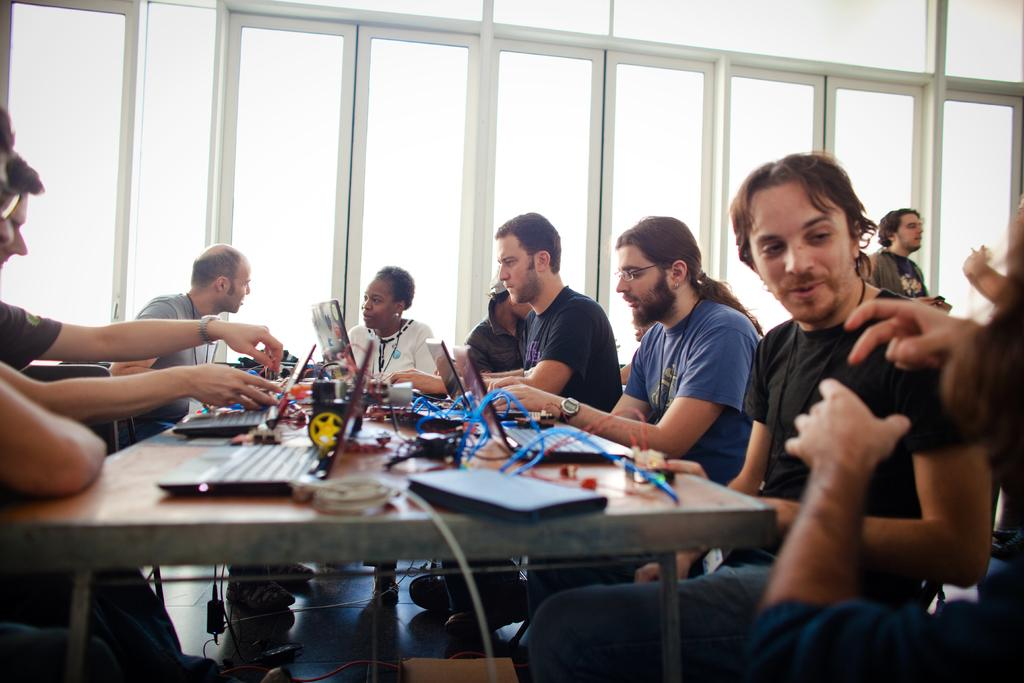What is happening in the image involving the group of people? The people in the image are sitting and speaking with each other. What objects can be seen on the table in the image? There are laptops and cables on the table in the image. What is visible in the background of the image? There is a window in the background of the image. How many brothers are present in the image? There is no mention of brothers in the image, so it cannot be determined from the provided facts. What type of building is visible through the window in the image? The image does not provide enough information to determine the type of building visible through the window. 